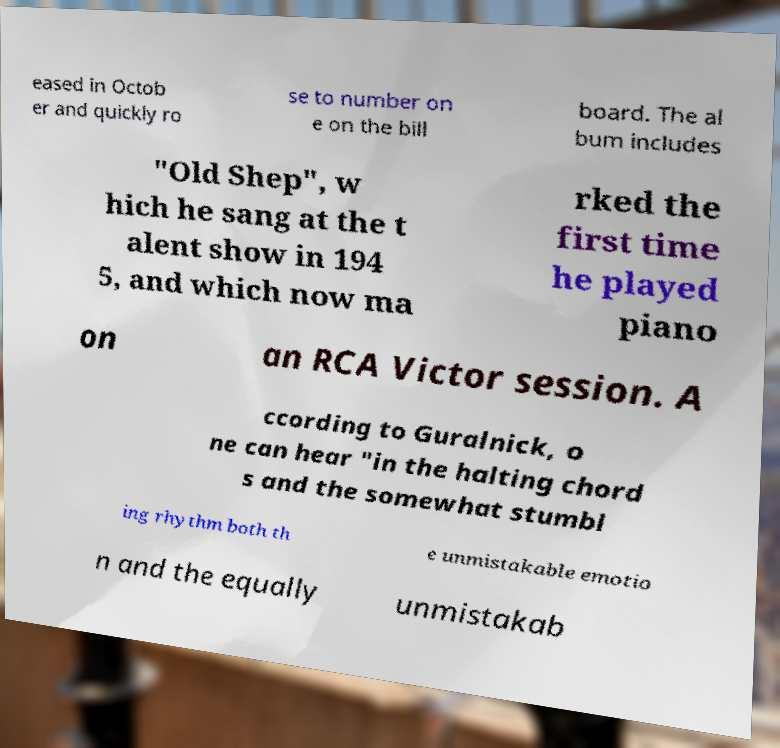There's text embedded in this image that I need extracted. Can you transcribe it verbatim? eased in Octob er and quickly ro se to number on e on the bill board. The al bum includes "Old Shep", w hich he sang at the t alent show in 194 5, and which now ma rked the first time he played piano on an RCA Victor session. A ccording to Guralnick, o ne can hear "in the halting chord s and the somewhat stumbl ing rhythm both th e unmistakable emotio n and the equally unmistakab 